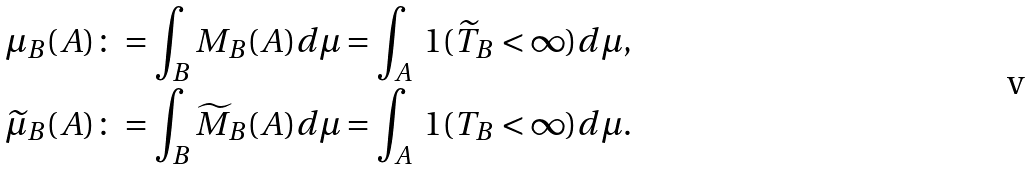Convert formula to latex. <formula><loc_0><loc_0><loc_500><loc_500>\mu _ { B } ( A ) & \colon = \int _ { B } M _ { B } ( A ) d \mu = \int _ { A } \ 1 ( \widetilde { T } _ { B } < \infty ) d \mu , \\ \widetilde { \mu } _ { B } ( A ) & \colon = \int _ { B } \widetilde { M } _ { B } ( A ) d \mu = \int _ { A } \ 1 ( T _ { B } < \infty ) d \mu .</formula> 